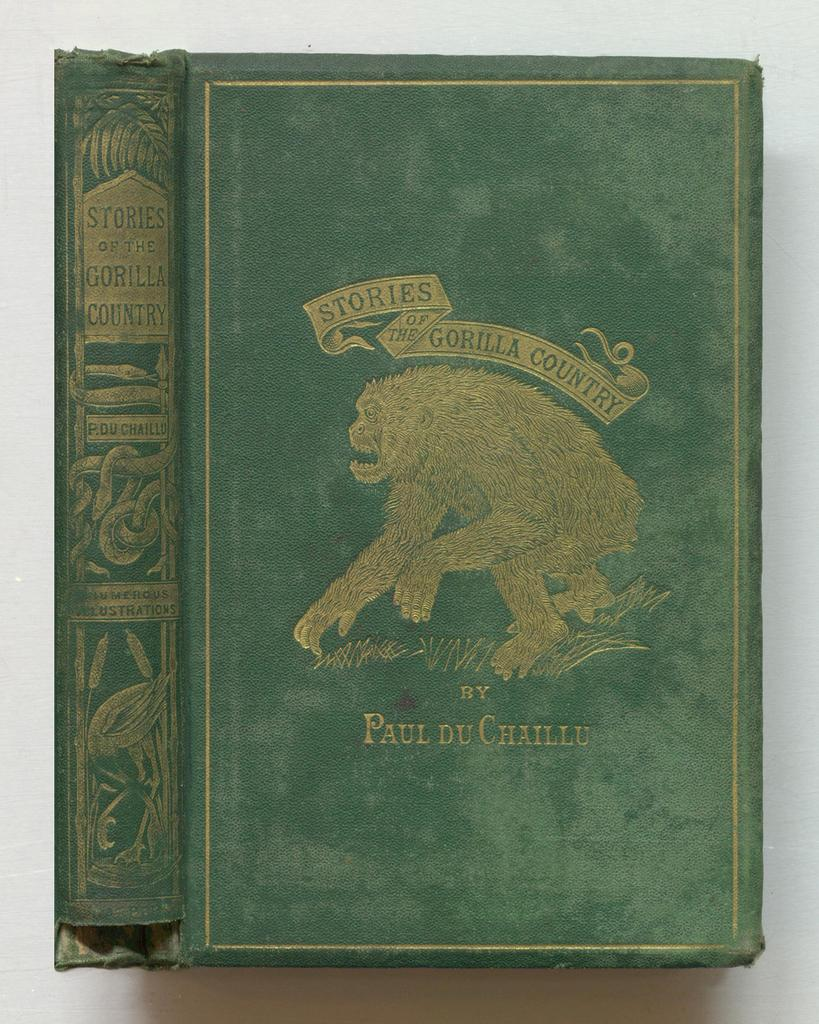<image>
Present a compact description of the photo's key features. A green book with a gorilla on the front called "Stories of The Gorilla Country". 